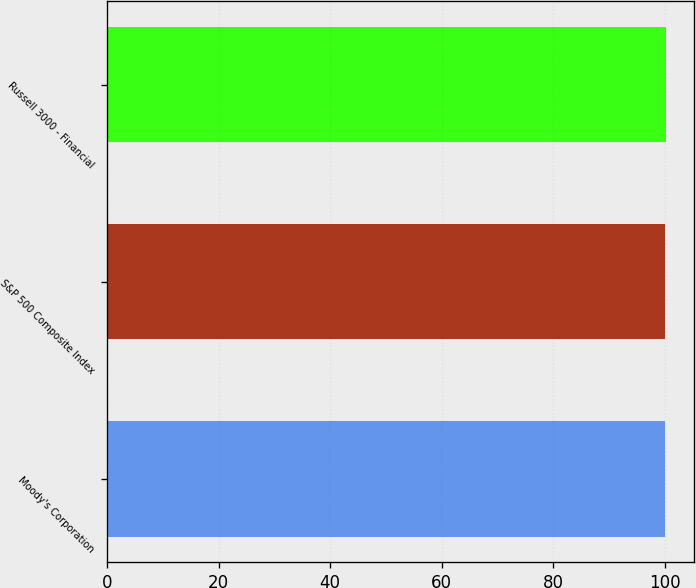Convert chart to OTSL. <chart><loc_0><loc_0><loc_500><loc_500><bar_chart><fcel>Moody's Corporation<fcel>S&P 500 Composite Index<fcel>Russell 3000 - Financial<nl><fcel>100<fcel>100.1<fcel>100.2<nl></chart> 